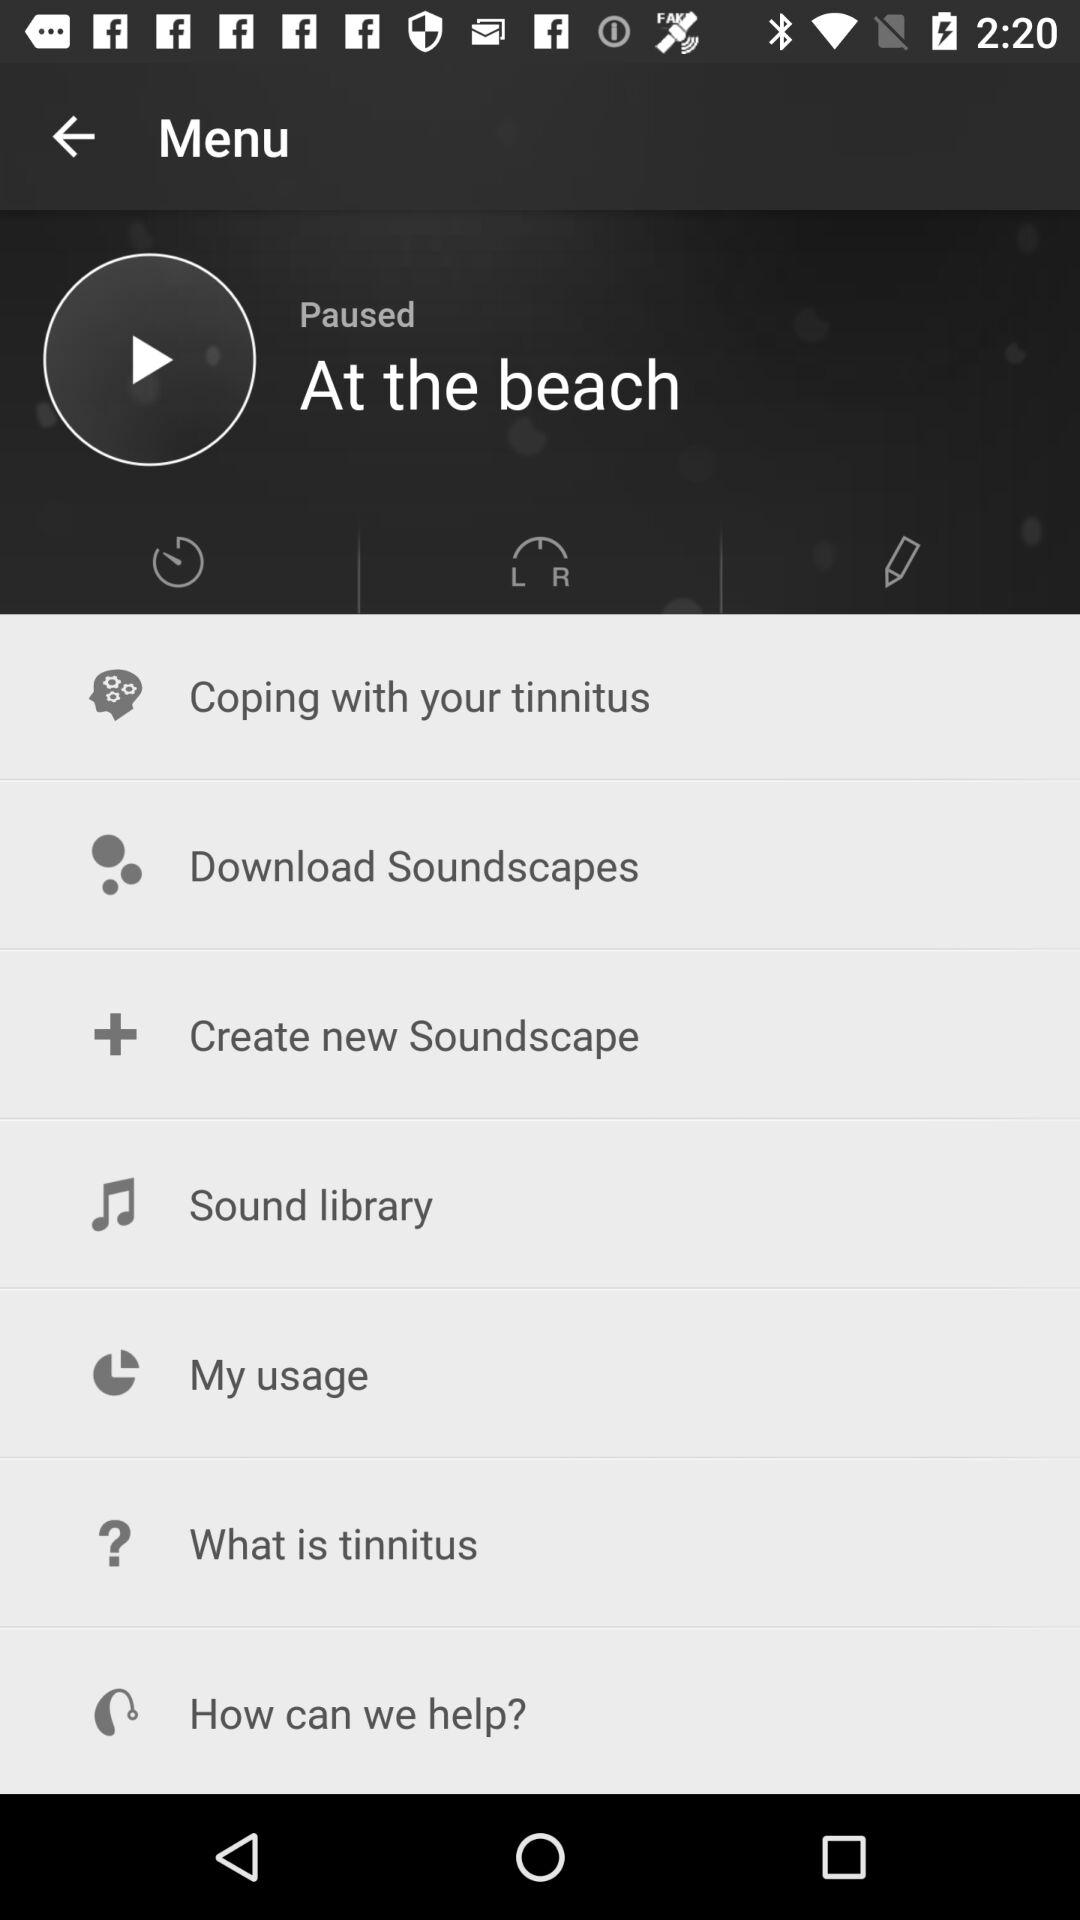How many notifications are there in "Sound library"?
When the provided information is insufficient, respond with <no answer>. <no answer> 